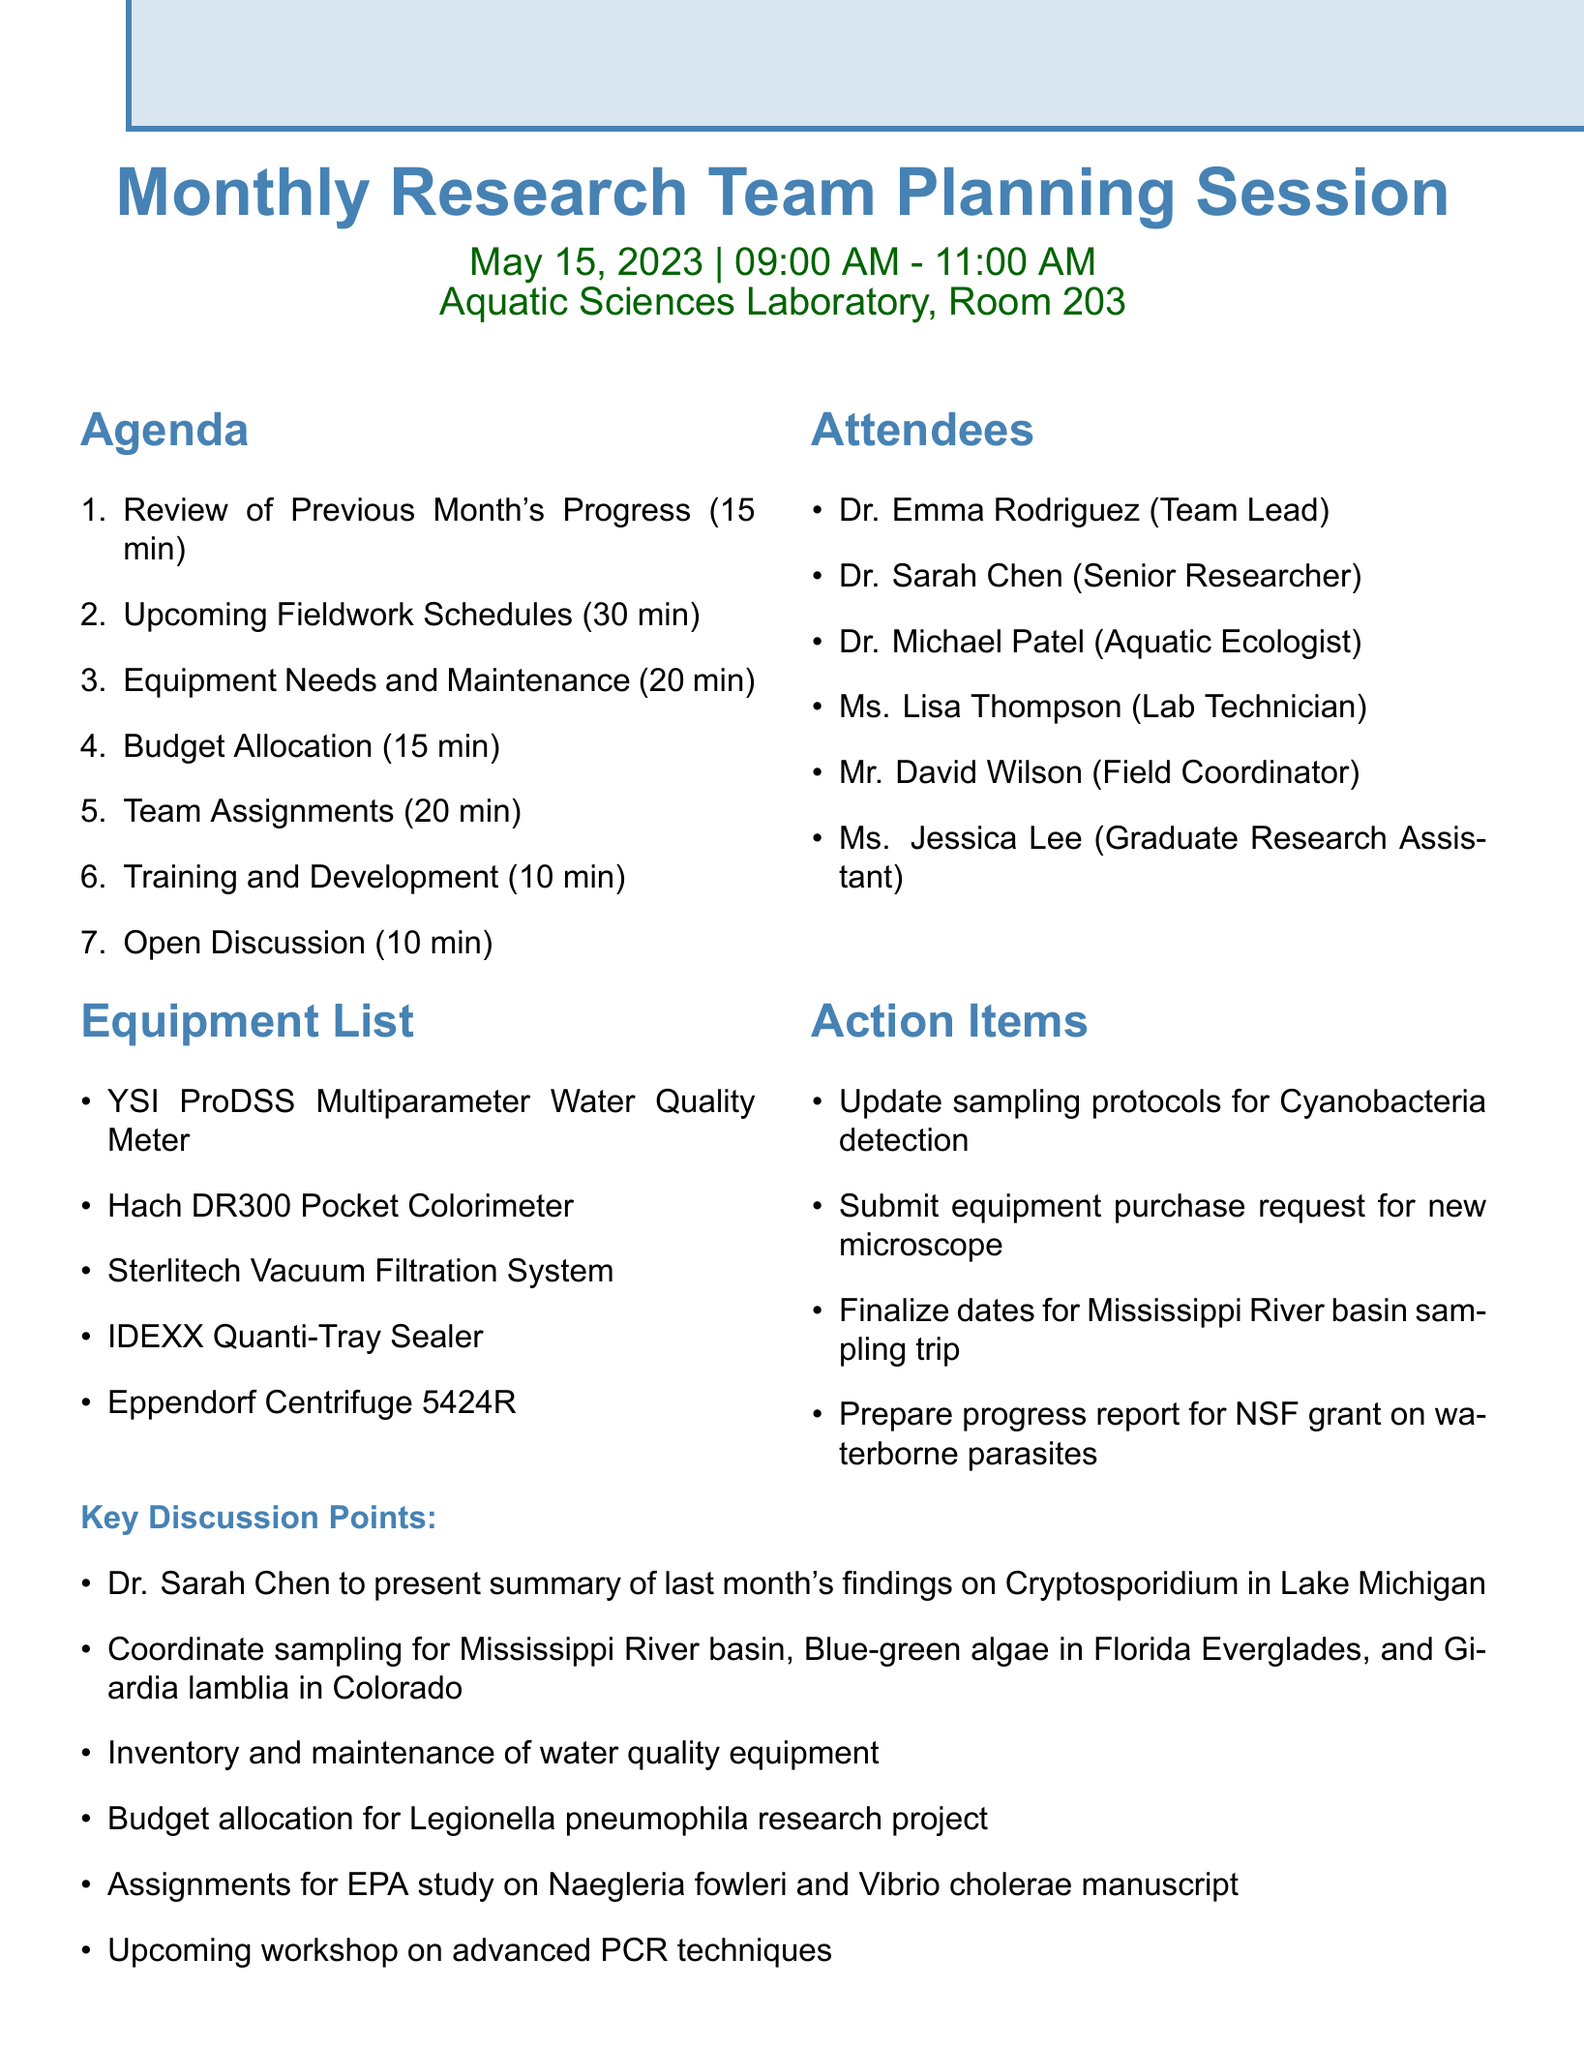What is the meeting date? The meeting date is explicitly stated in the meeting details section of the document.
Answer: May 15, 2023 Who is presenting the summary of last month's findings? The agenda item specifies that Dr. Sarah Chen is responsible for this presentation, highlighting her role in the meeting.
Answer: Dr. Sarah Chen How long is the discussion on upcoming fieldwork schedules? The duration for this agenda item is clearly mentioned, allowing us to ascertain the time allocated.
Answer: 30 minutes What is one of the equipment needs discussed? The document lists several equipment needs, allowing us to identify key items discussed.
Answer: Olympus BX53 microscope How many attendees are listed? The number of attendees is provided in the attendees section, which informs us of the team size.
Answer: 6 What is one action item related to sampling protocols? The action items section includes specific actions that need to be taken, indicating tasks for the team.
Answer: Update sampling protocols for Cyanobacteria detection What overall topic is scheduled for the last part of the meeting? The last item in the agenda addresses an open discussion, representing the opportunity for team input.
Answer: Open Discussion What is the time range for the meeting? The time for the meeting is explicitly stated, which helps us understand when the meeting occurs.
Answer: 09:00 AM - 11:00 AM 